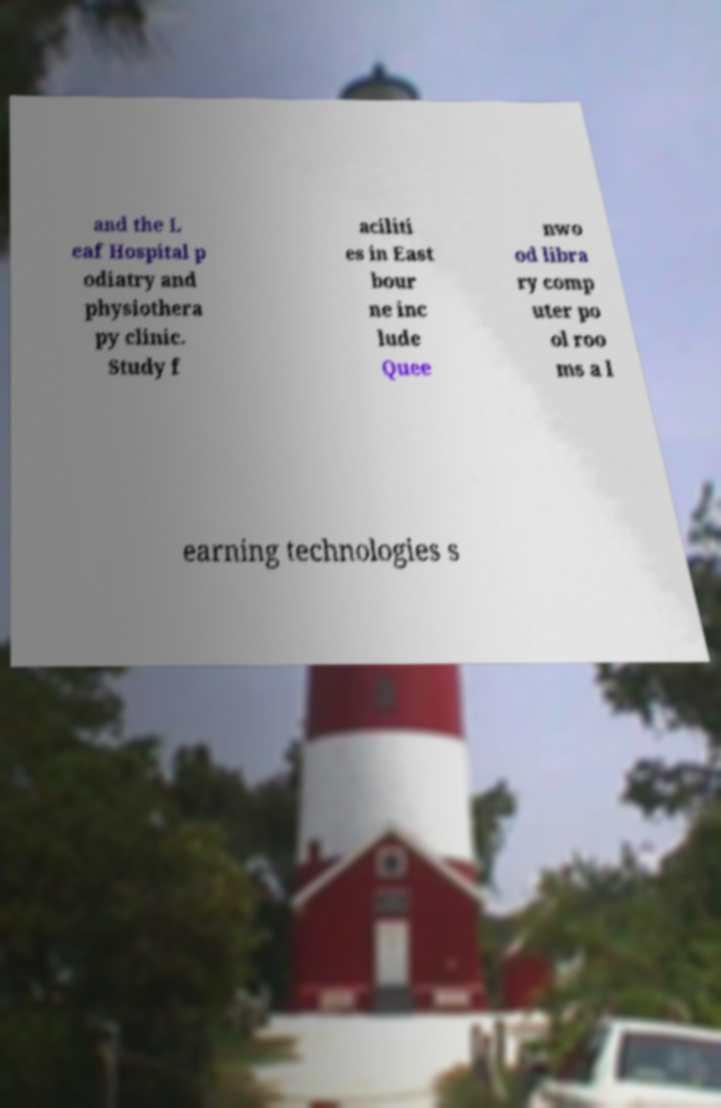What messages or text are displayed in this image? I need them in a readable, typed format. and the L eaf Hospital p odiatry and physiothera py clinic. Study f aciliti es in East bour ne inc lude Quee nwo od libra ry comp uter po ol roo ms a l earning technologies s 